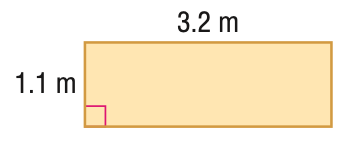Question: Find the area of the figure. Round to the nearest tenth.
Choices:
A. 1.2
B. 3.5
C. 8.6
D. 10.2
Answer with the letter. Answer: B Question: Find the perimeter or circumference of the figure. Round to the nearest tenth.
Choices:
A. 4.3
B. 8
C. 8.6
D. 17.2
Answer with the letter. Answer: C 